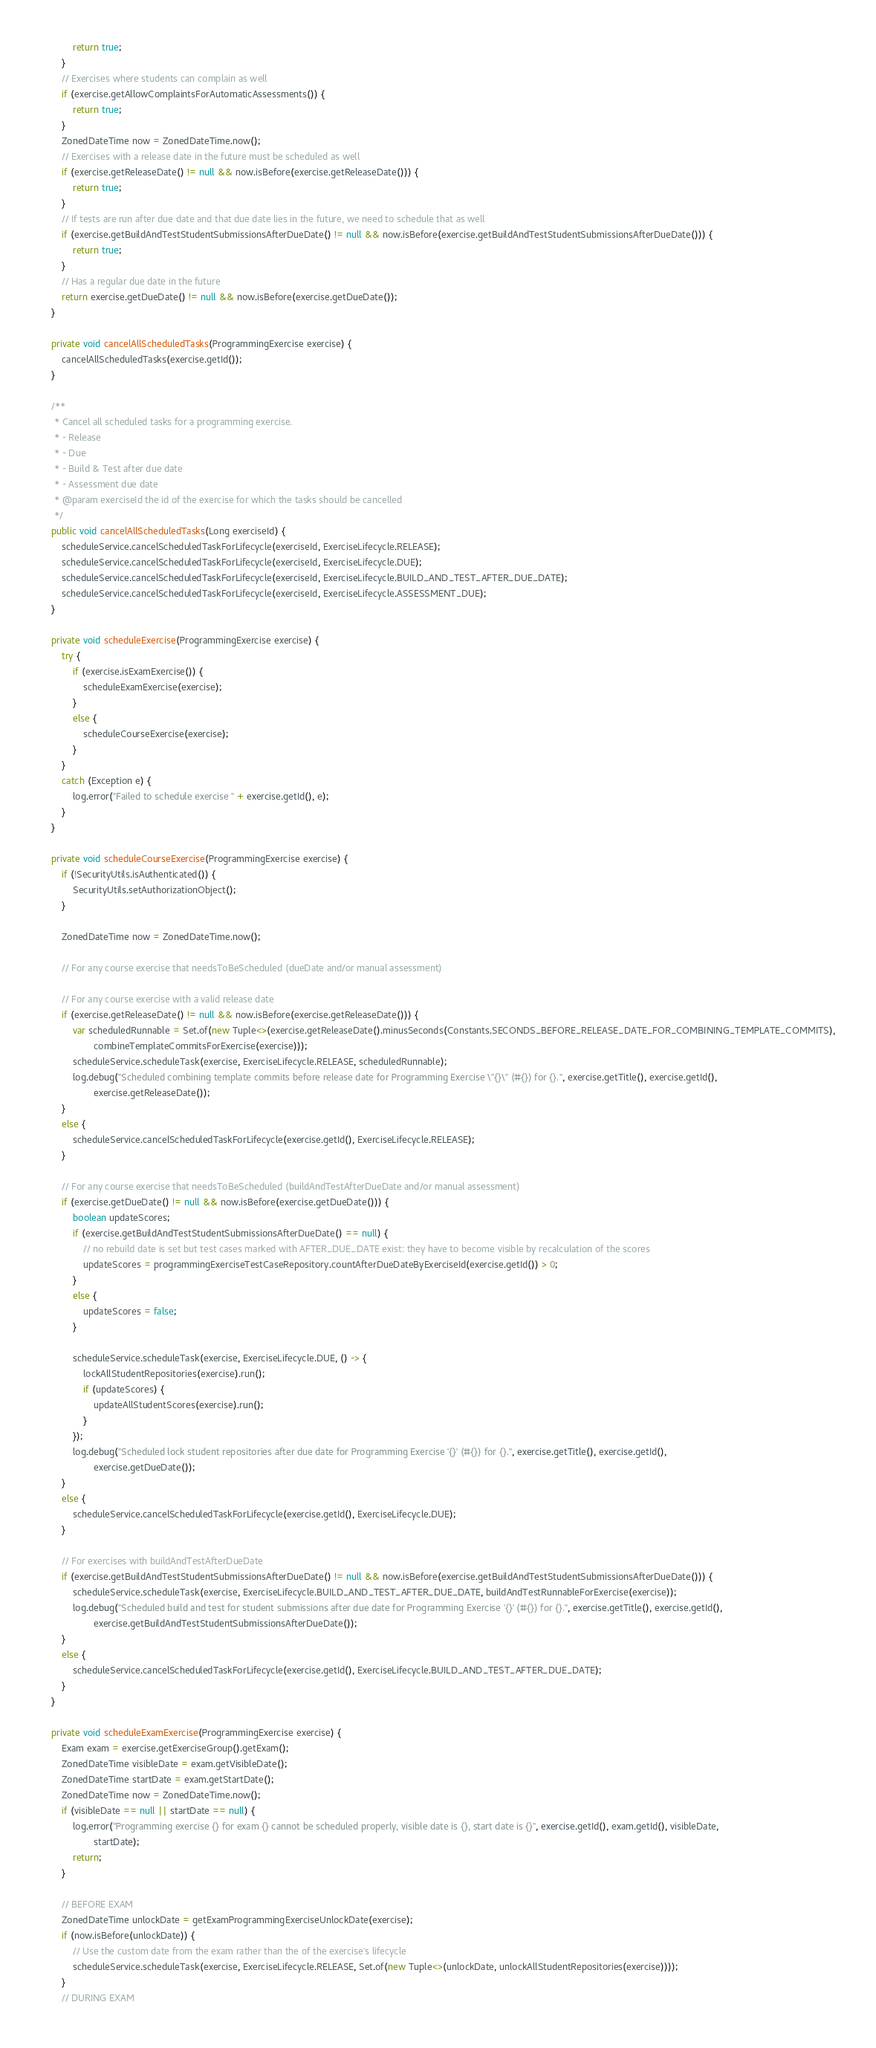Convert code to text. <code><loc_0><loc_0><loc_500><loc_500><_Java_>            return true;
        }
        // Exercises where students can complain as well
        if (exercise.getAllowComplaintsForAutomaticAssessments()) {
            return true;
        }
        ZonedDateTime now = ZonedDateTime.now();
        // Exercises with a release date in the future must be scheduled as well
        if (exercise.getReleaseDate() != null && now.isBefore(exercise.getReleaseDate())) {
            return true;
        }
        // If tests are run after due date and that due date lies in the future, we need to schedule that as well
        if (exercise.getBuildAndTestStudentSubmissionsAfterDueDate() != null && now.isBefore(exercise.getBuildAndTestStudentSubmissionsAfterDueDate())) {
            return true;
        }
        // Has a regular due date in the future
        return exercise.getDueDate() != null && now.isBefore(exercise.getDueDate());
    }

    private void cancelAllScheduledTasks(ProgrammingExercise exercise) {
        cancelAllScheduledTasks(exercise.getId());
    }

    /**
     * Cancel all scheduled tasks for a programming exercise.
     * - Release
     * - Due
     * - Build & Test after due date
     * - Assessment due date
     * @param exerciseId the id of the exercise for which the tasks should be cancelled
     */
    public void cancelAllScheduledTasks(Long exerciseId) {
        scheduleService.cancelScheduledTaskForLifecycle(exerciseId, ExerciseLifecycle.RELEASE);
        scheduleService.cancelScheduledTaskForLifecycle(exerciseId, ExerciseLifecycle.DUE);
        scheduleService.cancelScheduledTaskForLifecycle(exerciseId, ExerciseLifecycle.BUILD_AND_TEST_AFTER_DUE_DATE);
        scheduleService.cancelScheduledTaskForLifecycle(exerciseId, ExerciseLifecycle.ASSESSMENT_DUE);
    }

    private void scheduleExercise(ProgrammingExercise exercise) {
        try {
            if (exercise.isExamExercise()) {
                scheduleExamExercise(exercise);
            }
            else {
                scheduleCourseExercise(exercise);
            }
        }
        catch (Exception e) {
            log.error("Failed to schedule exercise " + exercise.getId(), e);
        }
    }

    private void scheduleCourseExercise(ProgrammingExercise exercise) {
        if (!SecurityUtils.isAuthenticated()) {
            SecurityUtils.setAuthorizationObject();
        }

        ZonedDateTime now = ZonedDateTime.now();

        // For any course exercise that needsToBeScheduled (dueDate and/or manual assessment)

        // For any course exercise with a valid release date
        if (exercise.getReleaseDate() != null && now.isBefore(exercise.getReleaseDate())) {
            var scheduledRunnable = Set.of(new Tuple<>(exercise.getReleaseDate().minusSeconds(Constants.SECONDS_BEFORE_RELEASE_DATE_FOR_COMBINING_TEMPLATE_COMMITS),
                    combineTemplateCommitsForExercise(exercise)));
            scheduleService.scheduleTask(exercise, ExerciseLifecycle.RELEASE, scheduledRunnable);
            log.debug("Scheduled combining template commits before release date for Programming Exercise \"{}\" (#{}) for {}.", exercise.getTitle(), exercise.getId(),
                    exercise.getReleaseDate());
        }
        else {
            scheduleService.cancelScheduledTaskForLifecycle(exercise.getId(), ExerciseLifecycle.RELEASE);
        }

        // For any course exercise that needsToBeScheduled (buildAndTestAfterDueDate and/or manual assessment)
        if (exercise.getDueDate() != null && now.isBefore(exercise.getDueDate())) {
            boolean updateScores;
            if (exercise.getBuildAndTestStudentSubmissionsAfterDueDate() == null) {
                // no rebuild date is set but test cases marked with AFTER_DUE_DATE exist: they have to become visible by recalculation of the scores
                updateScores = programmingExerciseTestCaseRepository.countAfterDueDateByExerciseId(exercise.getId()) > 0;
            }
            else {
                updateScores = false;
            }

            scheduleService.scheduleTask(exercise, ExerciseLifecycle.DUE, () -> {
                lockAllStudentRepositories(exercise).run();
                if (updateScores) {
                    updateAllStudentScores(exercise).run();
                }
            });
            log.debug("Scheduled lock student repositories after due date for Programming Exercise '{}' (#{}) for {}.", exercise.getTitle(), exercise.getId(),
                    exercise.getDueDate());
        }
        else {
            scheduleService.cancelScheduledTaskForLifecycle(exercise.getId(), ExerciseLifecycle.DUE);
        }

        // For exercises with buildAndTestAfterDueDate
        if (exercise.getBuildAndTestStudentSubmissionsAfterDueDate() != null && now.isBefore(exercise.getBuildAndTestStudentSubmissionsAfterDueDate())) {
            scheduleService.scheduleTask(exercise, ExerciseLifecycle.BUILD_AND_TEST_AFTER_DUE_DATE, buildAndTestRunnableForExercise(exercise));
            log.debug("Scheduled build and test for student submissions after due date for Programming Exercise '{}' (#{}) for {}.", exercise.getTitle(), exercise.getId(),
                    exercise.getBuildAndTestStudentSubmissionsAfterDueDate());
        }
        else {
            scheduleService.cancelScheduledTaskForLifecycle(exercise.getId(), ExerciseLifecycle.BUILD_AND_TEST_AFTER_DUE_DATE);
        }
    }

    private void scheduleExamExercise(ProgrammingExercise exercise) {
        Exam exam = exercise.getExerciseGroup().getExam();
        ZonedDateTime visibleDate = exam.getVisibleDate();
        ZonedDateTime startDate = exam.getStartDate();
        ZonedDateTime now = ZonedDateTime.now();
        if (visibleDate == null || startDate == null) {
            log.error("Programming exercise {} for exam {} cannot be scheduled properly, visible date is {}, start date is {}", exercise.getId(), exam.getId(), visibleDate,
                    startDate);
            return;
        }

        // BEFORE EXAM
        ZonedDateTime unlockDate = getExamProgrammingExerciseUnlockDate(exercise);
        if (now.isBefore(unlockDate)) {
            // Use the custom date from the exam rather than the of the exercise's lifecycle
            scheduleService.scheduleTask(exercise, ExerciseLifecycle.RELEASE, Set.of(new Tuple<>(unlockDate, unlockAllStudentRepositories(exercise))));
        }
        // DURING EXAM</code> 